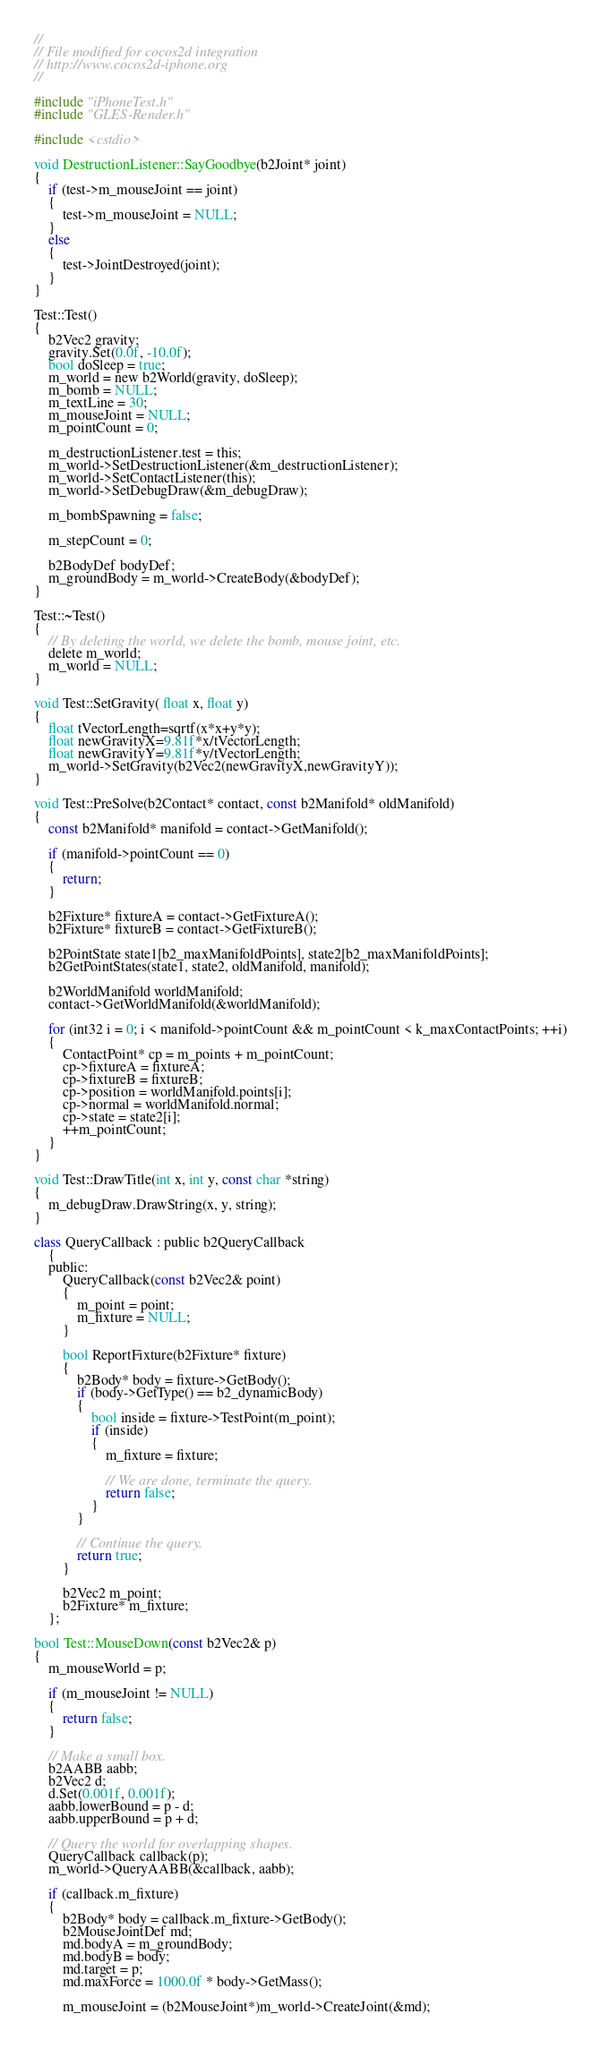<code> <loc_0><loc_0><loc_500><loc_500><_ObjectiveC_>
//
// File modified for cocos2d integration
// http://www.cocos2d-iphone.org
//

#include "iPhoneTest.h"
#include "GLES-Render.h"

#include <cstdio>

void DestructionListener::SayGoodbye(b2Joint* joint)
{
	if (test->m_mouseJoint == joint)
	{
		test->m_mouseJoint = NULL;
	}
	else
	{
		test->JointDestroyed(joint);
	}
}

Test::Test()
{
	b2Vec2 gravity;
	gravity.Set(0.0f, -10.0f);
	bool doSleep = true;
	m_world = new b2World(gravity, doSleep);
	m_bomb = NULL;
	m_textLine = 30;
	m_mouseJoint = NULL;
	m_pointCount = 0;
	
	m_destructionListener.test = this;
	m_world->SetDestructionListener(&m_destructionListener);
	m_world->SetContactListener(this);
	m_world->SetDebugDraw(&m_debugDraw);
	
	m_bombSpawning = false;
	
	m_stepCount = 0;
	
	b2BodyDef bodyDef;
	m_groundBody = m_world->CreateBody(&bodyDef);
}

Test::~Test()
{
	// By deleting the world, we delete the bomb, mouse joint, etc.
	delete m_world;
	m_world = NULL;
}

void Test::SetGravity( float x, float y)
{
	float tVectorLength=sqrtf(x*x+y*y);
	float newGravityX=9.81f*x/tVectorLength;
	float newGravityY=9.81f*y/tVectorLength;
	m_world->SetGravity(b2Vec2(newGravityX,newGravityY));	
}

void Test::PreSolve(b2Contact* contact, const b2Manifold* oldManifold)
{
	const b2Manifold* manifold = contact->GetManifold();
	
	if (manifold->pointCount == 0)
	{
		return;
	}
	
	b2Fixture* fixtureA = contact->GetFixtureA();
	b2Fixture* fixtureB = contact->GetFixtureB();
	
	b2PointState state1[b2_maxManifoldPoints], state2[b2_maxManifoldPoints];
	b2GetPointStates(state1, state2, oldManifold, manifold);
	
	b2WorldManifold worldManifold;
	contact->GetWorldManifold(&worldManifold);
	
	for (int32 i = 0; i < manifold->pointCount && m_pointCount < k_maxContactPoints; ++i)
	{
		ContactPoint* cp = m_points + m_pointCount;
		cp->fixtureA = fixtureA;
		cp->fixtureB = fixtureB;
		cp->position = worldManifold.points[i];
		cp->normal = worldManifold.normal;
		cp->state = state2[i];
		++m_pointCount;
	}
}

void Test::DrawTitle(int x, int y, const char *string)
{
    m_debugDraw.DrawString(x, y, string);
}

class QueryCallback : public b2QueryCallback
	{
	public:
		QueryCallback(const b2Vec2& point)
		{
			m_point = point;
			m_fixture = NULL;
		}
		
		bool ReportFixture(b2Fixture* fixture)
		{
			b2Body* body = fixture->GetBody();
			if (body->GetType() == b2_dynamicBody)
			{
				bool inside = fixture->TestPoint(m_point);
				if (inside)
				{
					m_fixture = fixture;
					
					// We are done, terminate the query.
					return false;
				}
			}
			
			// Continue the query.
			return true;
		}
		
		b2Vec2 m_point;
		b2Fixture* m_fixture;
	};

bool Test::MouseDown(const b2Vec2& p)
{
	m_mouseWorld = p;
	
	if (m_mouseJoint != NULL)
	{
		return false;
	}
	
	// Make a small box.
	b2AABB aabb;
	b2Vec2 d;
	d.Set(0.001f, 0.001f);
	aabb.lowerBound = p - d;
	aabb.upperBound = p + d;
	
	// Query the world for overlapping shapes.
	QueryCallback callback(p);
	m_world->QueryAABB(&callback, aabb);
	
	if (callback.m_fixture)
	{
		b2Body* body = callback.m_fixture->GetBody();
		b2MouseJointDef md;
		md.bodyA = m_groundBody;
		md.bodyB = body;
		md.target = p;
		md.maxForce = 1000.0f * body->GetMass();

		m_mouseJoint = (b2MouseJoint*)m_world->CreateJoint(&md);</code> 